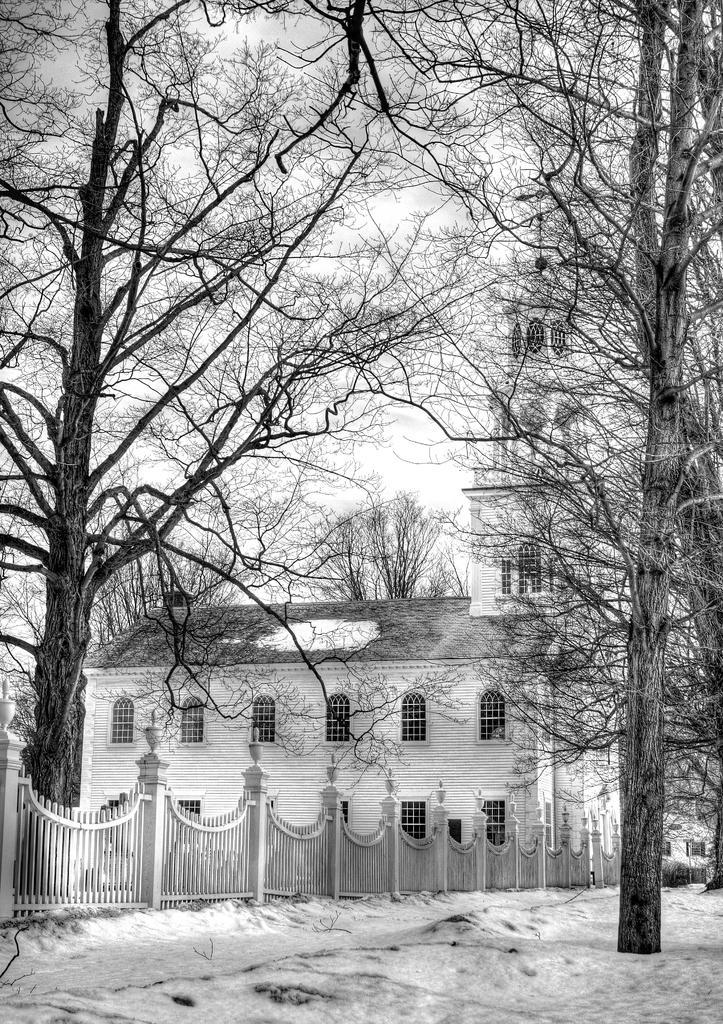Please provide a concise description of this image. In this image I can see the snow, railing and the house with windows. To the side of the house I can see many trees. In the background I can see the sky. 